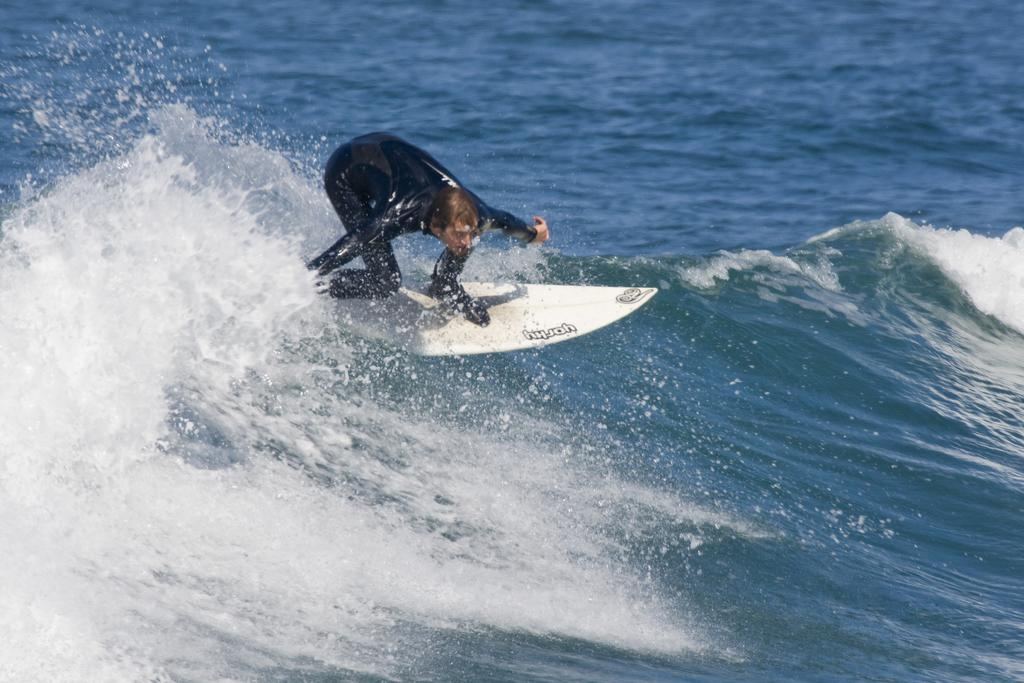What is present in the image? There is water and a man in the image. What is the man wearing? The man is wearing a black color swimsuit. What is the man doing in the water? The man is surfing. What type of brush is the man using to paint the water in the image? There is no brush present in the image, and the man is not painting the water; he is surfing. 